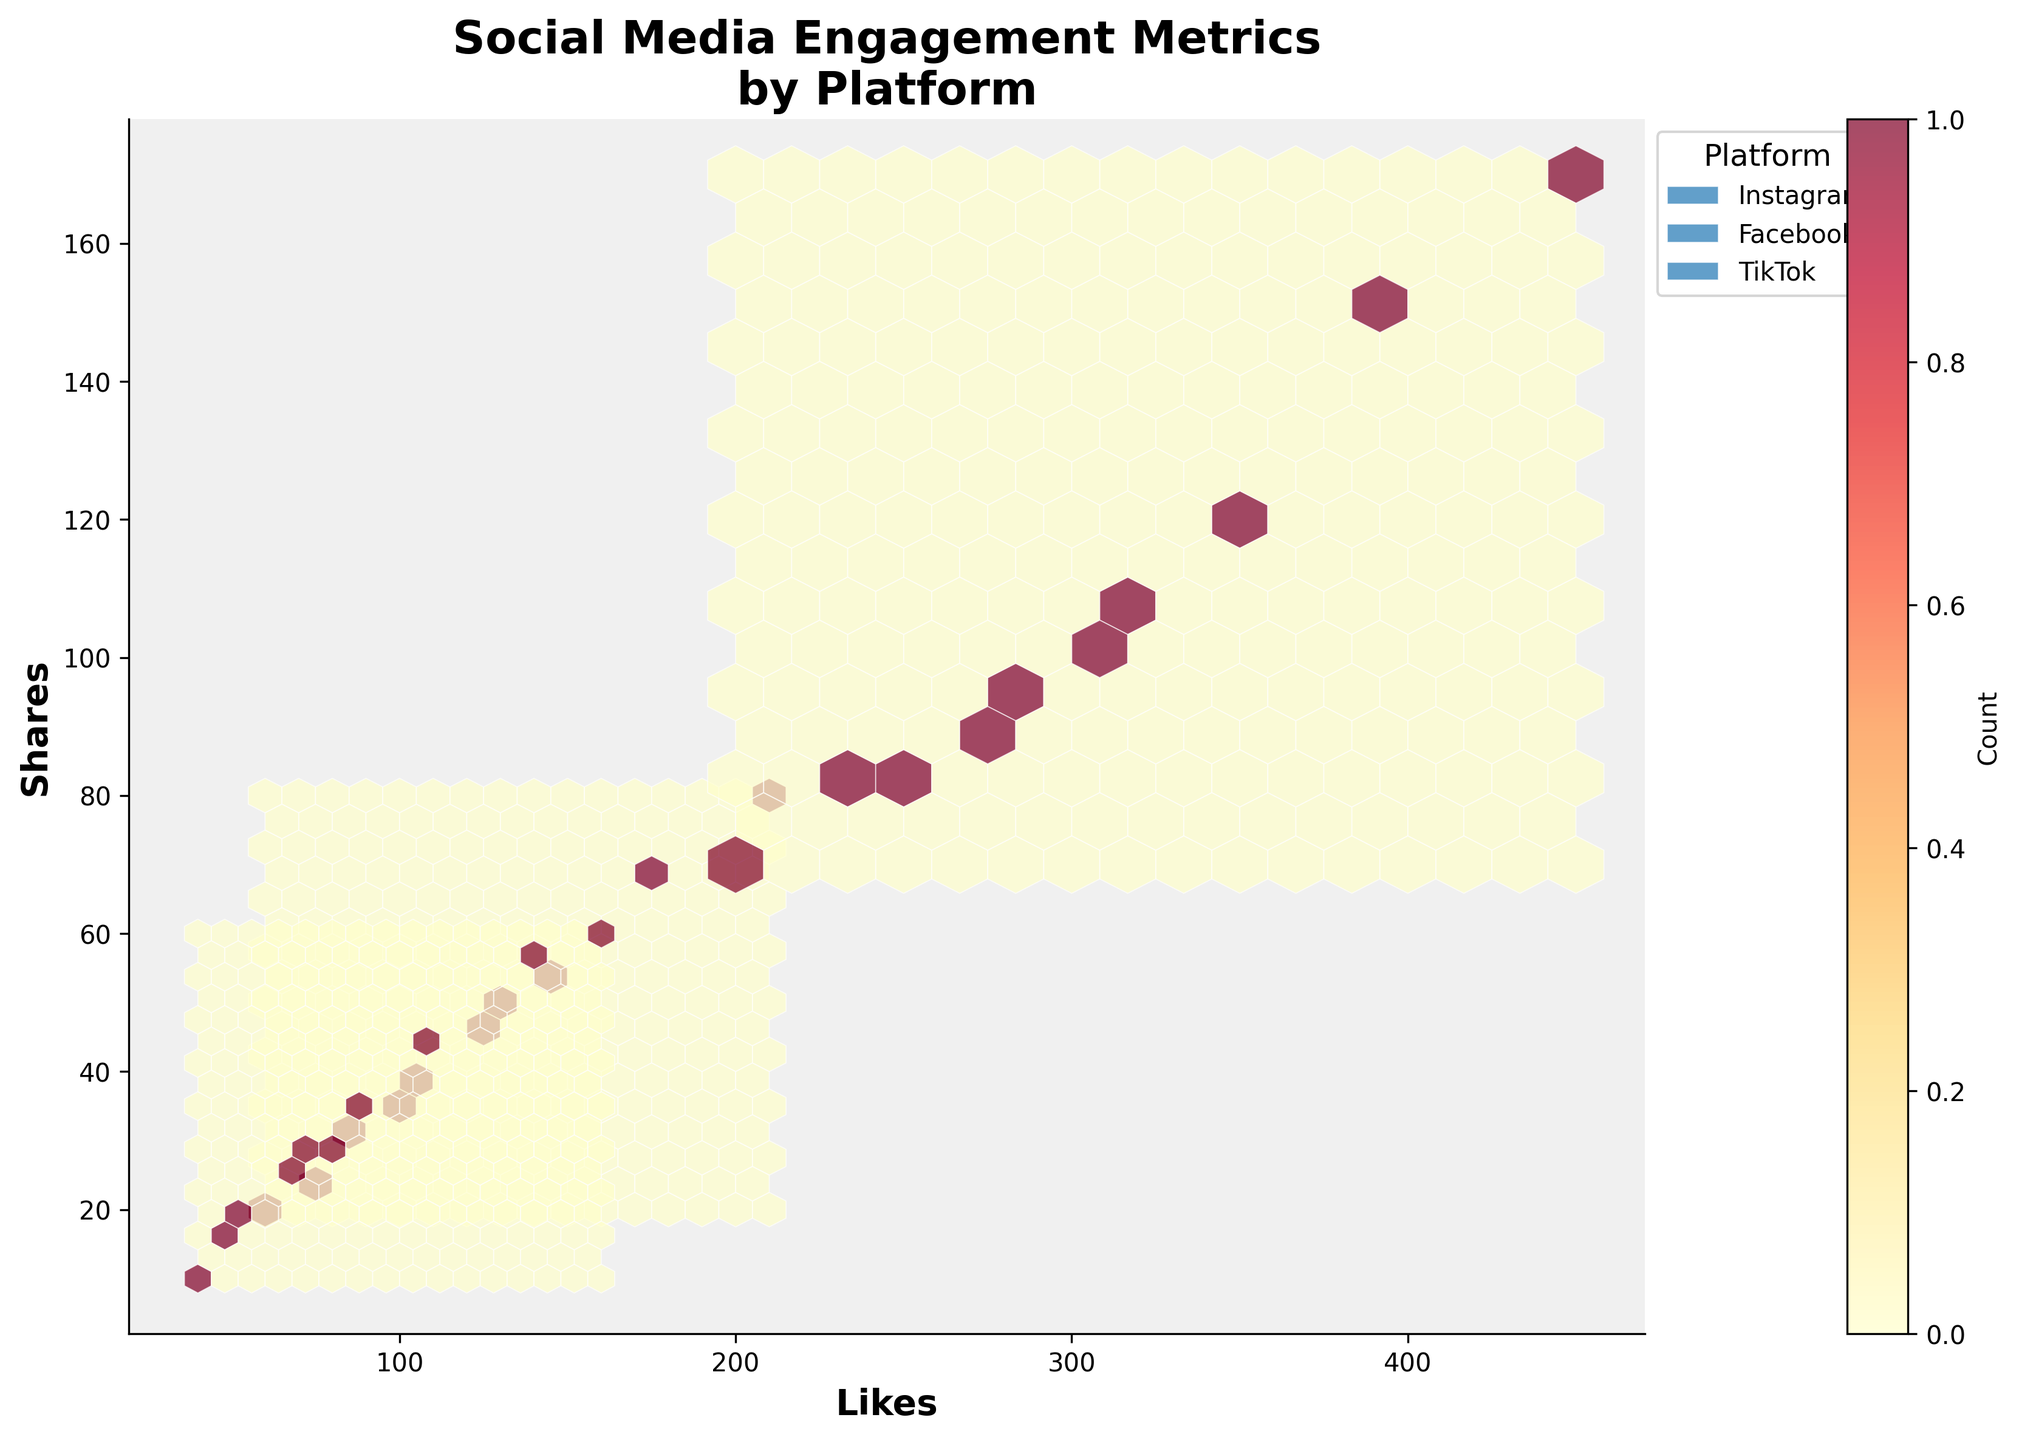What does the title of the figure say? The title of the figure can be read at the top of the plot. It is often descriptive of the content visualized.
Answer: Social Media Engagement Metrics by Platform Which platform has the highest concentration of likes above 300? By examining the density of hexagons in the plot, particularly focusing on the likes axis above the 300 mark, we observe which platform's hexes are more concentrated in that area.
Answer: TikTok What does the color bar represent? The color bar usually found beside the hexbin plot indicates the density of the observations. The different hues represent different counts of data points within each hexagon.
Answer: Count Comparing Instagram and Facebook, which platform generally shows a higher number of likes in their engagements? By observing the spread of hexagons for both platforms, we compare their general locations on the likes axis.
Answer: Instagram What is the range of the "Shares" axis in the plot? We can determine the range by looking at the minimum and maximum values on the shares axis.
Answer: 0 to 170 Which platform's engagement metrics are most evenly distributed in the plot? By assessing the spread of hexagons across the axes for each platform, we determine which platform has a more even distribution across likes and shares.
Answer: Facebook How many platforms are represented in the legend? The legend, often found to the side or bottom of the plot, lists all the categories (platforms) represented in the hexbin plot.
Answer: Three Between which two platforms does the maximum overlap in engagement occur? By observing the density and overlap of hexagons from different platforms, we identify where the maximum overlap exists.
Answer: Instagram and Facebook What is the average number of likes for content on TikTok? To find this, calculate the mean value of likes for TikTok by summing up all the likes and dividing by the number of TikTok data points. Calculation: (300+250+400+200+350+280+450+230+320+270)/10 = 305
Answer: 305 Which platform shows the highest diversity in likes? We observe the spread of hexagons along the likes axis for each platform to see which has the widest range.
Answer: TikTok 